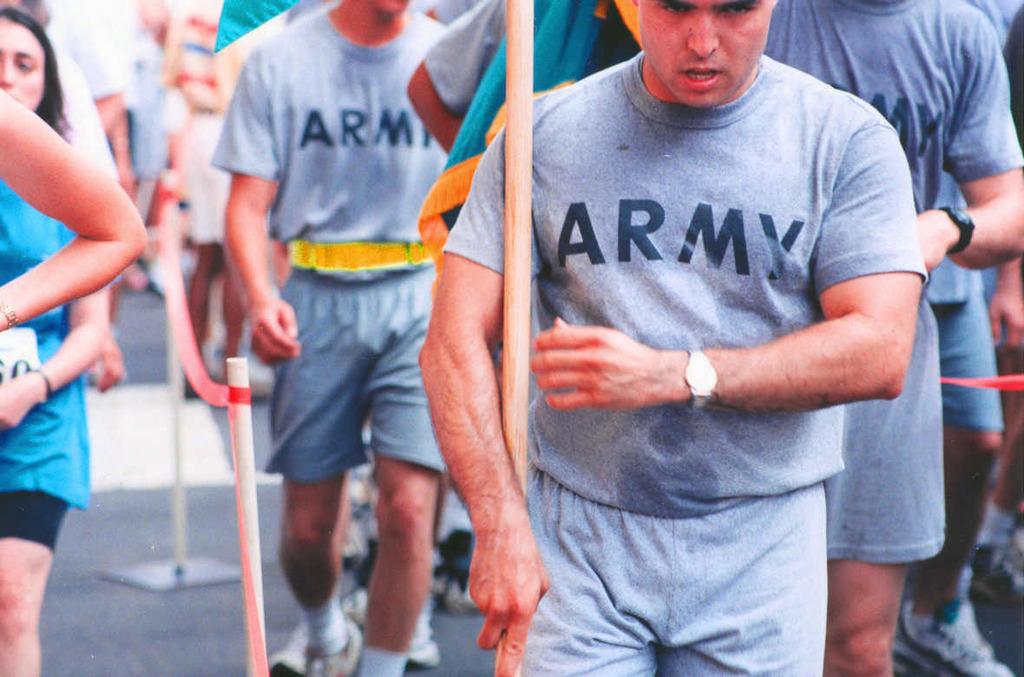What military branch do they represent?
Make the answer very short. Army. 